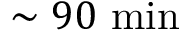<formula> <loc_0><loc_0><loc_500><loc_500>\sim 9 0 \min</formula> 